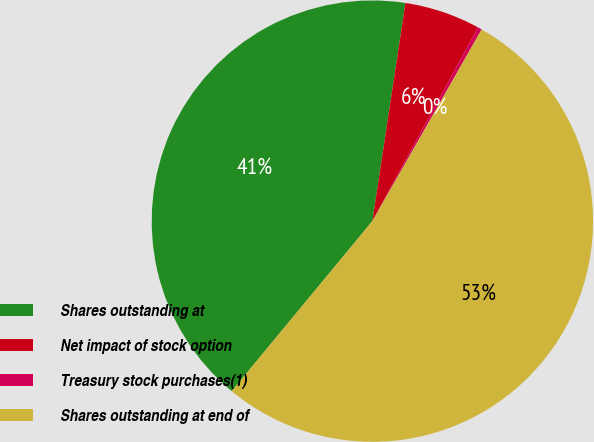<chart> <loc_0><loc_0><loc_500><loc_500><pie_chart><fcel>Shares outstanding at<fcel>Net impact of stock option<fcel>Treasury stock purchases(1)<fcel>Shares outstanding at end of<nl><fcel>41.4%<fcel>5.55%<fcel>0.3%<fcel>52.76%<nl></chart> 